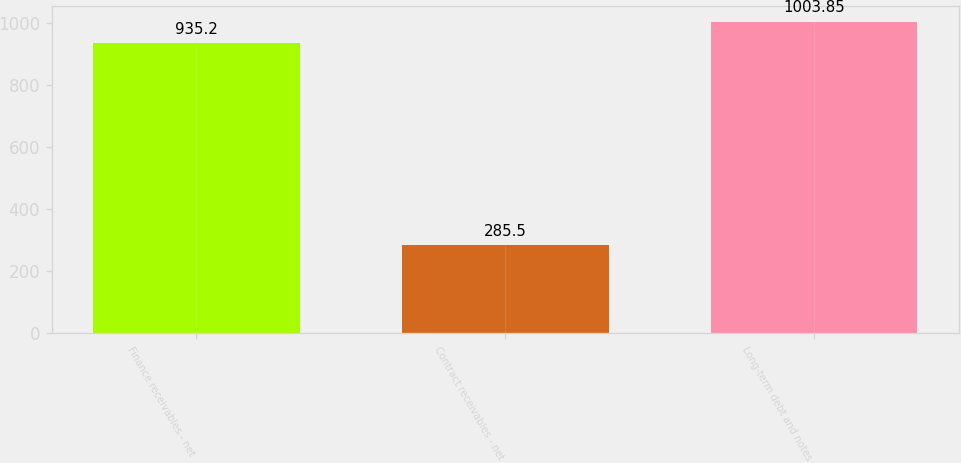<chart> <loc_0><loc_0><loc_500><loc_500><bar_chart><fcel>Finance receivables - net<fcel>Contract receivables - net<fcel>Long-term debt and notes<nl><fcel>935.2<fcel>285.5<fcel>1003.85<nl></chart> 